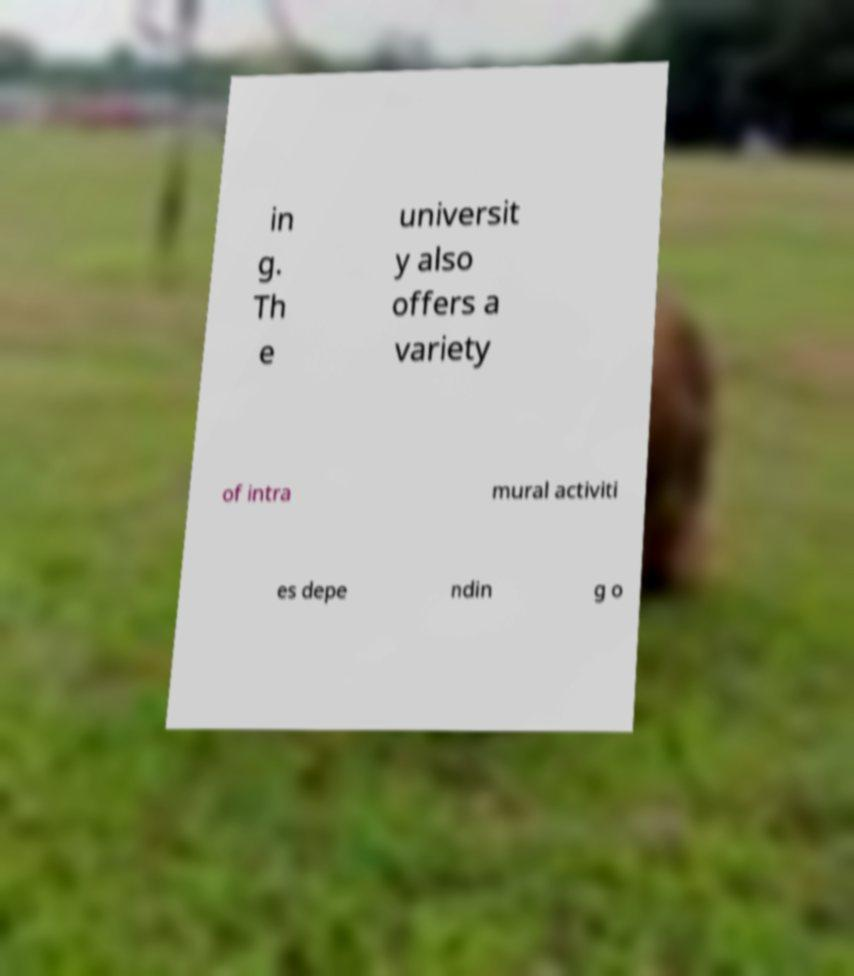What messages or text are displayed in this image? I need them in a readable, typed format. in g. Th e universit y also offers a variety of intra mural activiti es depe ndin g o 